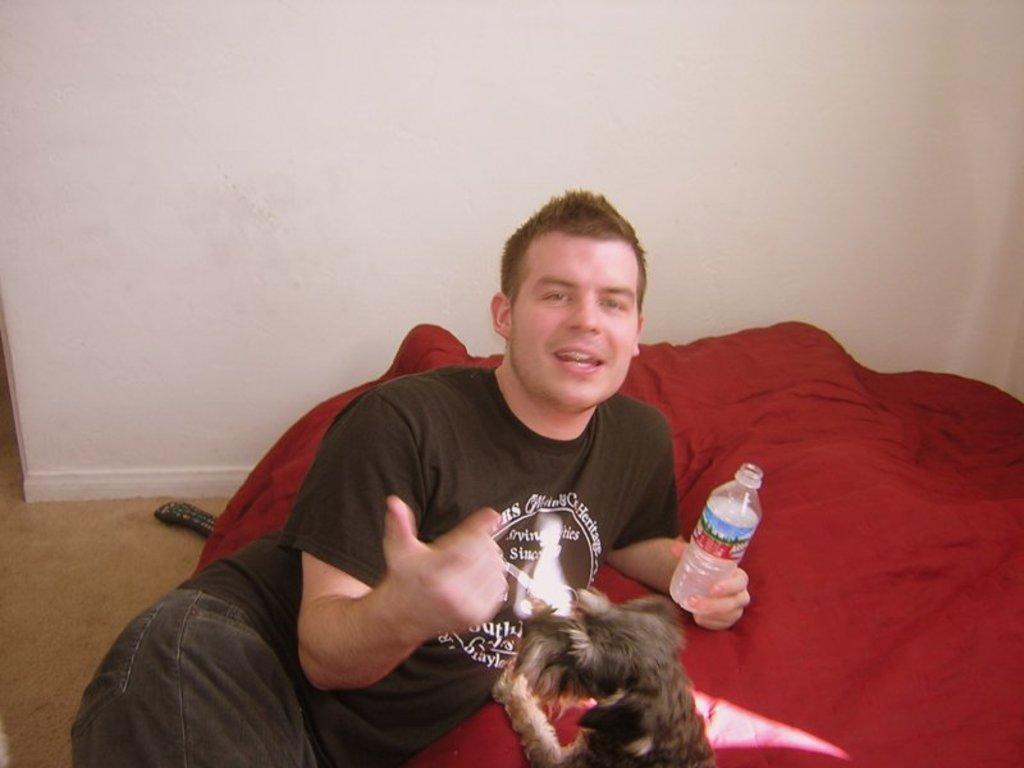How would you summarize this image in a sentence or two? Man lying holding a bottle beside the dog and remote in the back there is wall. 